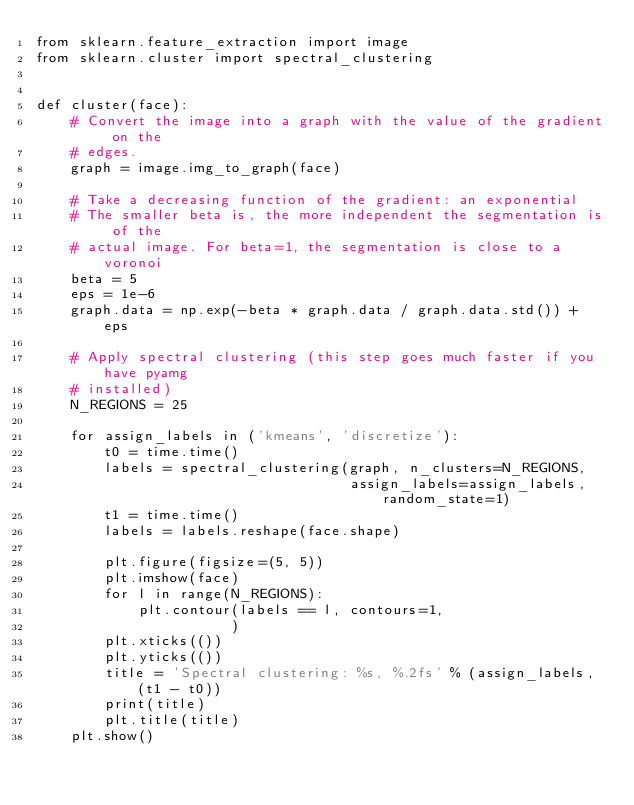Convert code to text. <code><loc_0><loc_0><loc_500><loc_500><_Python_>from sklearn.feature_extraction import image
from sklearn.cluster import spectral_clustering


def cluster(face):
    # Convert the image into a graph with the value of the gradient on the
    # edges.
    graph = image.img_to_graph(face)
    
    # Take a decreasing function of the gradient: an exponential
    # The smaller beta is, the more independent the segmentation is of the
    # actual image. For beta=1, the segmentation is close to a voronoi
    beta = 5
    eps = 1e-6
    graph.data = np.exp(-beta * graph.data / graph.data.std()) + eps
    
    # Apply spectral clustering (this step goes much faster if you have pyamg
    # installed)
    N_REGIONS = 25
    
    for assign_labels in ('kmeans', 'discretize'):
        t0 = time.time()
        labels = spectral_clustering(graph, n_clusters=N_REGIONS,
                                     assign_labels=assign_labels, random_state=1)
        t1 = time.time()
        labels = labels.reshape(face.shape)
    
        plt.figure(figsize=(5, 5))
        plt.imshow(face)
        for l in range(N_REGIONS):
            plt.contour(labels == l, contours=1,
                       )
        plt.xticks(())
        plt.yticks(())
        title = 'Spectral clustering: %s, %.2fs' % (assign_labels, (t1 - t0))
        print(title)
        plt.title(title)
    plt.show()</code> 